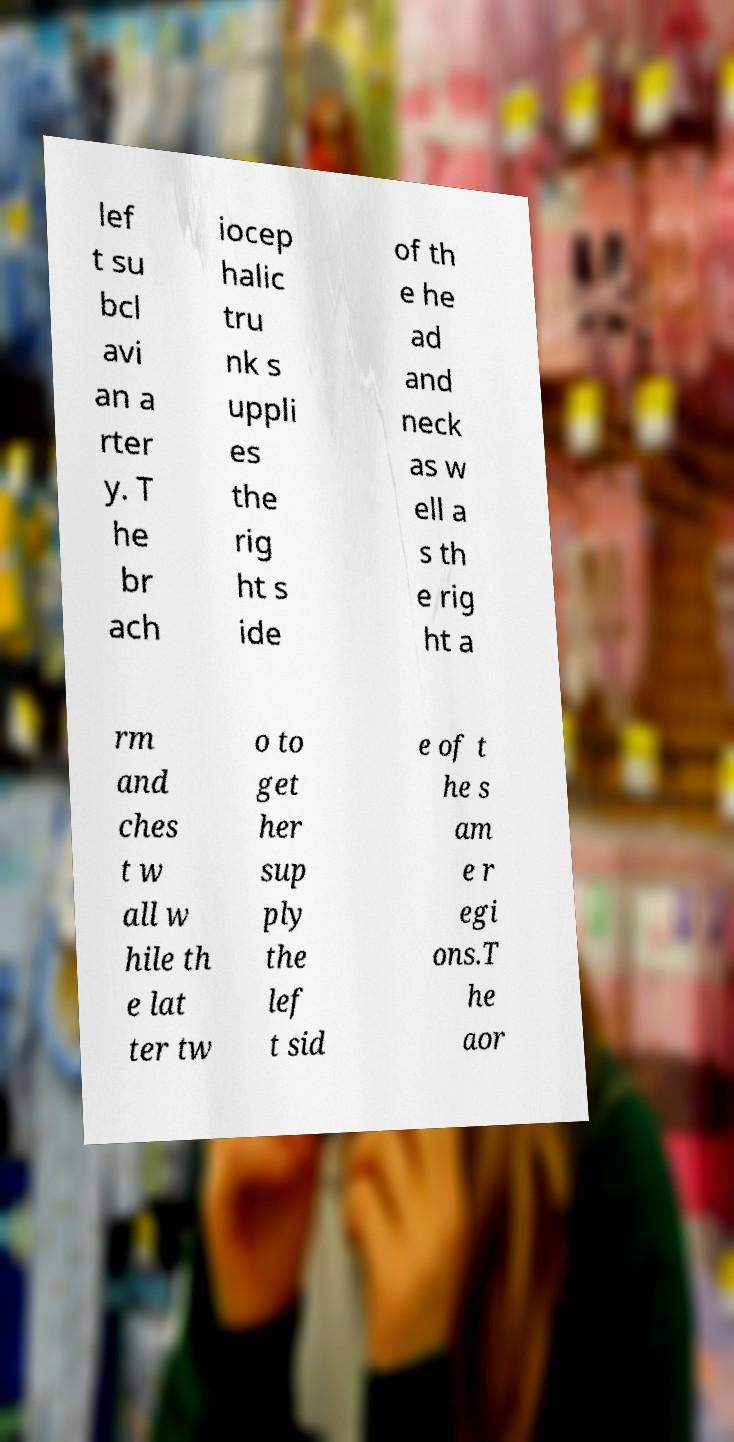Could you assist in decoding the text presented in this image and type it out clearly? lef t su bcl avi an a rter y. T he br ach iocep halic tru nk s uppli es the rig ht s ide of th e he ad and neck as w ell a s th e rig ht a rm and ches t w all w hile th e lat ter tw o to get her sup ply the lef t sid e of t he s am e r egi ons.T he aor 